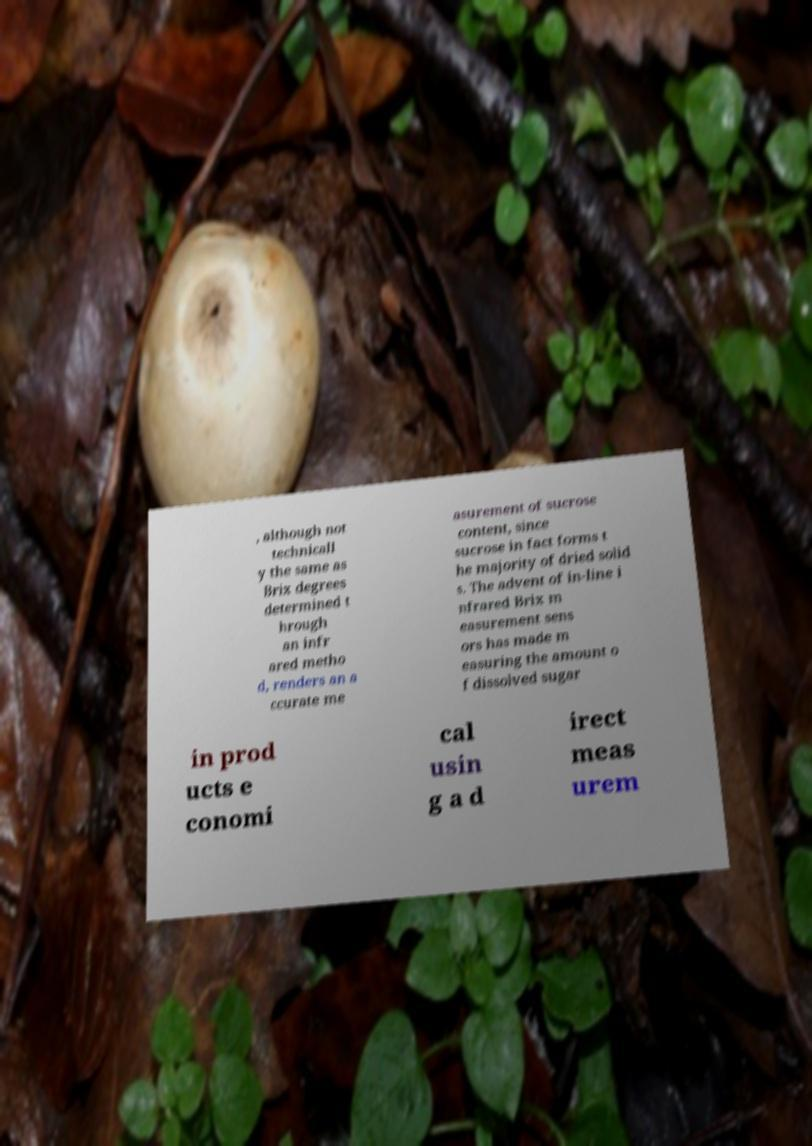Please read and relay the text visible in this image. What does it say? , although not technicall y the same as Brix degrees determined t hrough an infr ared metho d, renders an a ccurate me asurement of sucrose content, since sucrose in fact forms t he majority of dried solid s. The advent of in-line i nfrared Brix m easurement sens ors has made m easuring the amount o f dissolved sugar in prod ucts e conomi cal usin g a d irect meas urem 